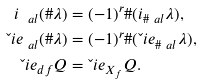<formula> <loc_0><loc_0><loc_500><loc_500>i _ { \ a l } ( \# \lambda ) & = ( - 1 ) ^ { r } \# ( i _ { \# \ a l } \lambda ) , \\ \L i e _ { \ a l } ( \# \lambda ) & = ( - 1 ) ^ { r } \# ( \L i e _ { \# \ a l } \lambda ) , \\ \L i e _ { d f } Q & = \L i e _ { X _ { f } } Q .</formula> 